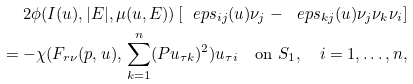<formula> <loc_0><loc_0><loc_500><loc_500>2 \phi ( I ( u ) , | E | , \mu ( u , E ) ) \left [ \ e p s _ { i j } ( u ) \nu _ { j } - \ e p s _ { k j } ( u ) \nu _ { j } \nu _ { k } \nu _ { i } \right ] \\ = - \chi ( F _ { r \nu } ( p , u ) , \, \sum _ { k = 1 } ^ { n } ( P u _ { \tau k } ) ^ { 2 } ) u _ { \tau i } \quad \text {on } S _ { 1 } , \quad i = 1 , \dots , n ,</formula> 